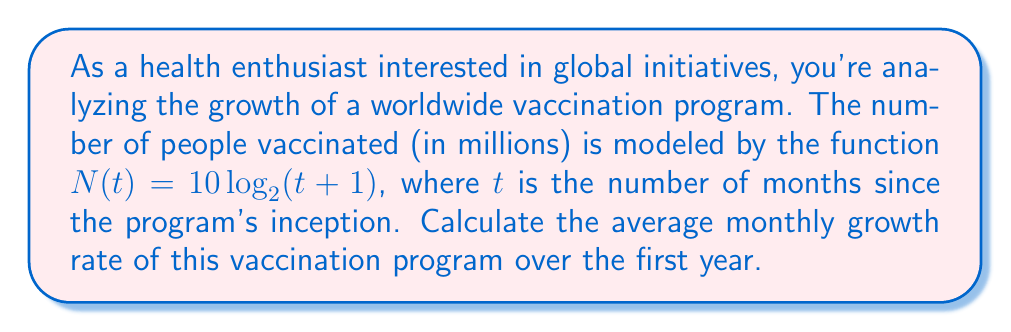Teach me how to tackle this problem. To solve this problem, we'll follow these steps:

1) First, we need to calculate the number of people vaccinated at the beginning ($t=0$) and end ($t=12$) of the first year.

2) At $t=0$:
   $N(0) = 10 \log_2(0+1) = 10 \log_2(1) = 10 \cdot 0 = 0$ million people

3) At $t=12$:
   $N(12) = 10 log_2(12+1) = 10 \log_2(13) \approx 36.54$ million people

4) The total growth over the year is:
   $36.54 - 0 = 36.54$ million people

5) To find the average monthly growth rate, we use the formula:
   $$r = \left(\frac{\text{End Value}}{\text{Start Value}}\right)^{\frac{1}{\text{Number of Periods}}} - 1$$

6) However, since our start value is 0, we can't use this formula directly. Instead, we'll consider the average absolute growth per month and then calculate the rate based on the end value.

7) Average absolute growth per month:
   $\frac{36.54}{12} = 3.045$ million people per month

8) This represents a monthly growth rate of:
   $$r = \frac{3.045}{36.54} \approx 0.0833 \text{ or } 8.33\%$$

Therefore, the average monthly growth rate is approximately 8.33%.
Answer: The average monthly growth rate of the vaccination program over the first year is approximately 8.33%. 